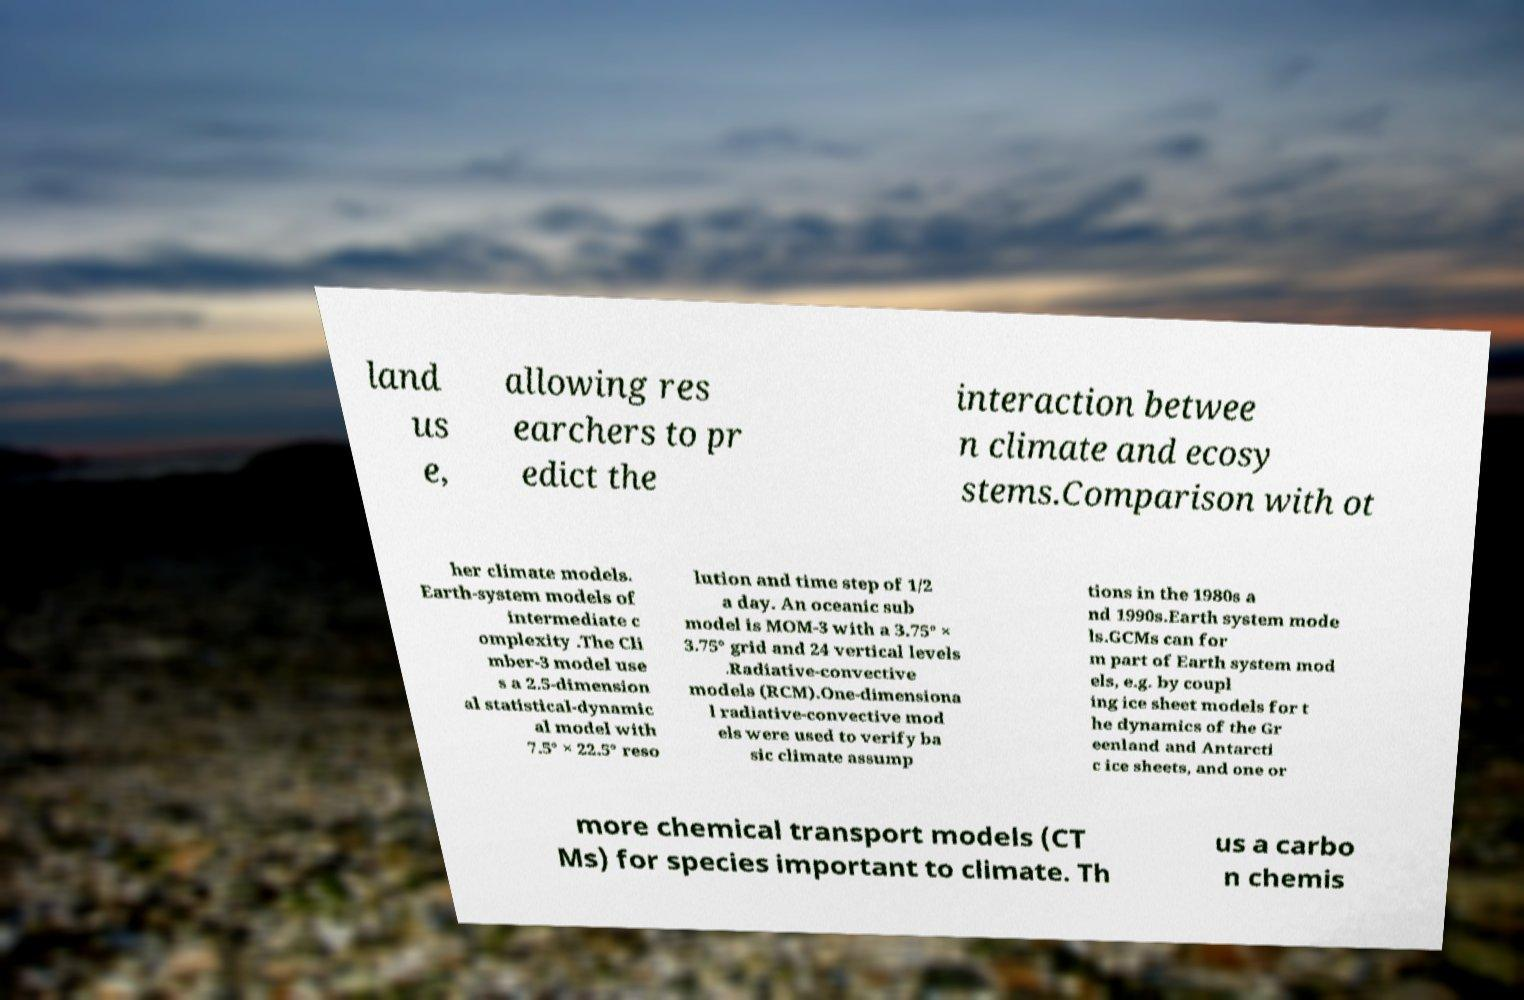What messages or text are displayed in this image? I need them in a readable, typed format. land us e, allowing res earchers to pr edict the interaction betwee n climate and ecosy stems.Comparison with ot her climate models. Earth-system models of intermediate c omplexity .The Cli mber-3 model use s a 2.5-dimension al statistical-dynamic al model with 7.5° × 22.5° reso lution and time step of 1/2 a day. An oceanic sub model is MOM-3 with a 3.75° × 3.75° grid and 24 vertical levels .Radiative-convective models (RCM).One-dimensiona l radiative-convective mod els were used to verify ba sic climate assump tions in the 1980s a nd 1990s.Earth system mode ls.GCMs can for m part of Earth system mod els, e.g. by coupl ing ice sheet models for t he dynamics of the Gr eenland and Antarcti c ice sheets, and one or more chemical transport models (CT Ms) for species important to climate. Th us a carbo n chemis 